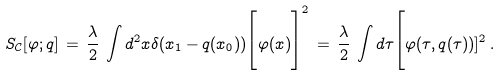<formula> <loc_0><loc_0><loc_500><loc_500>S _ { \mathcal { C } } [ \varphi ; q ] \, = \, \frac { \lambda } { 2 } \, \int d ^ { 2 } x \delta ( x _ { 1 } - q ( x _ { 0 } ) ) \Big [ \varphi ( x ) \Big ] ^ { 2 } \, = \, \frac { \lambda } { 2 } \, \int d \tau \Big [ \varphi ( \tau , q ( \tau ) ) ] ^ { 2 } \, .</formula> 